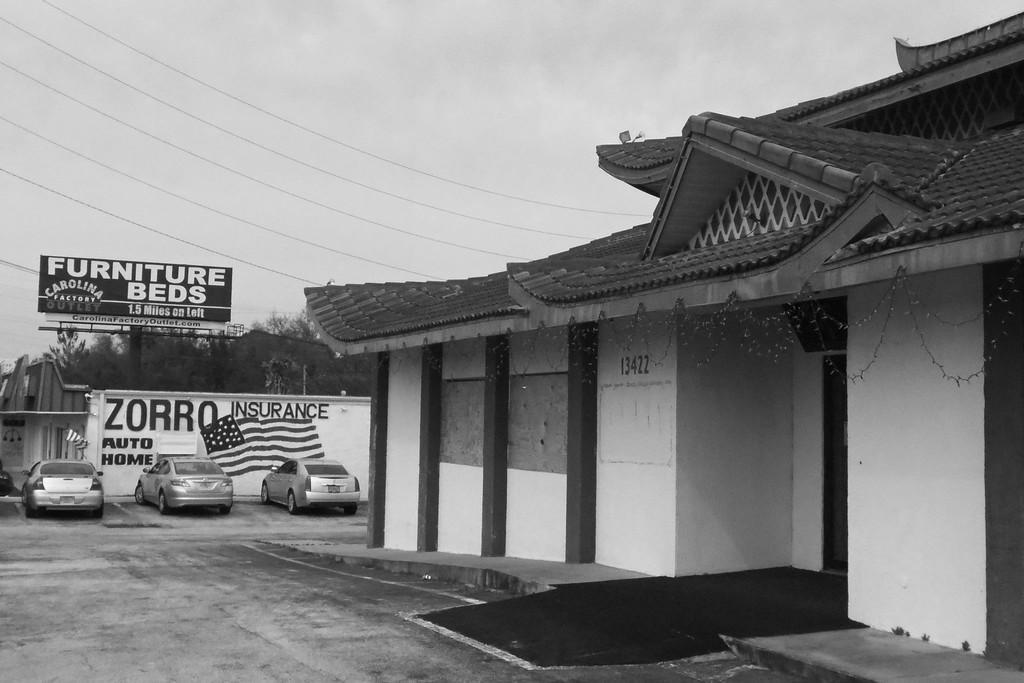In one or two sentences, can you explain what this image depicts? It is a black and white picture. In this image, we can see few houses, walls, hoardings, trees, vehicles and roads. Here we can see some text. Background there is the sky and wires. 